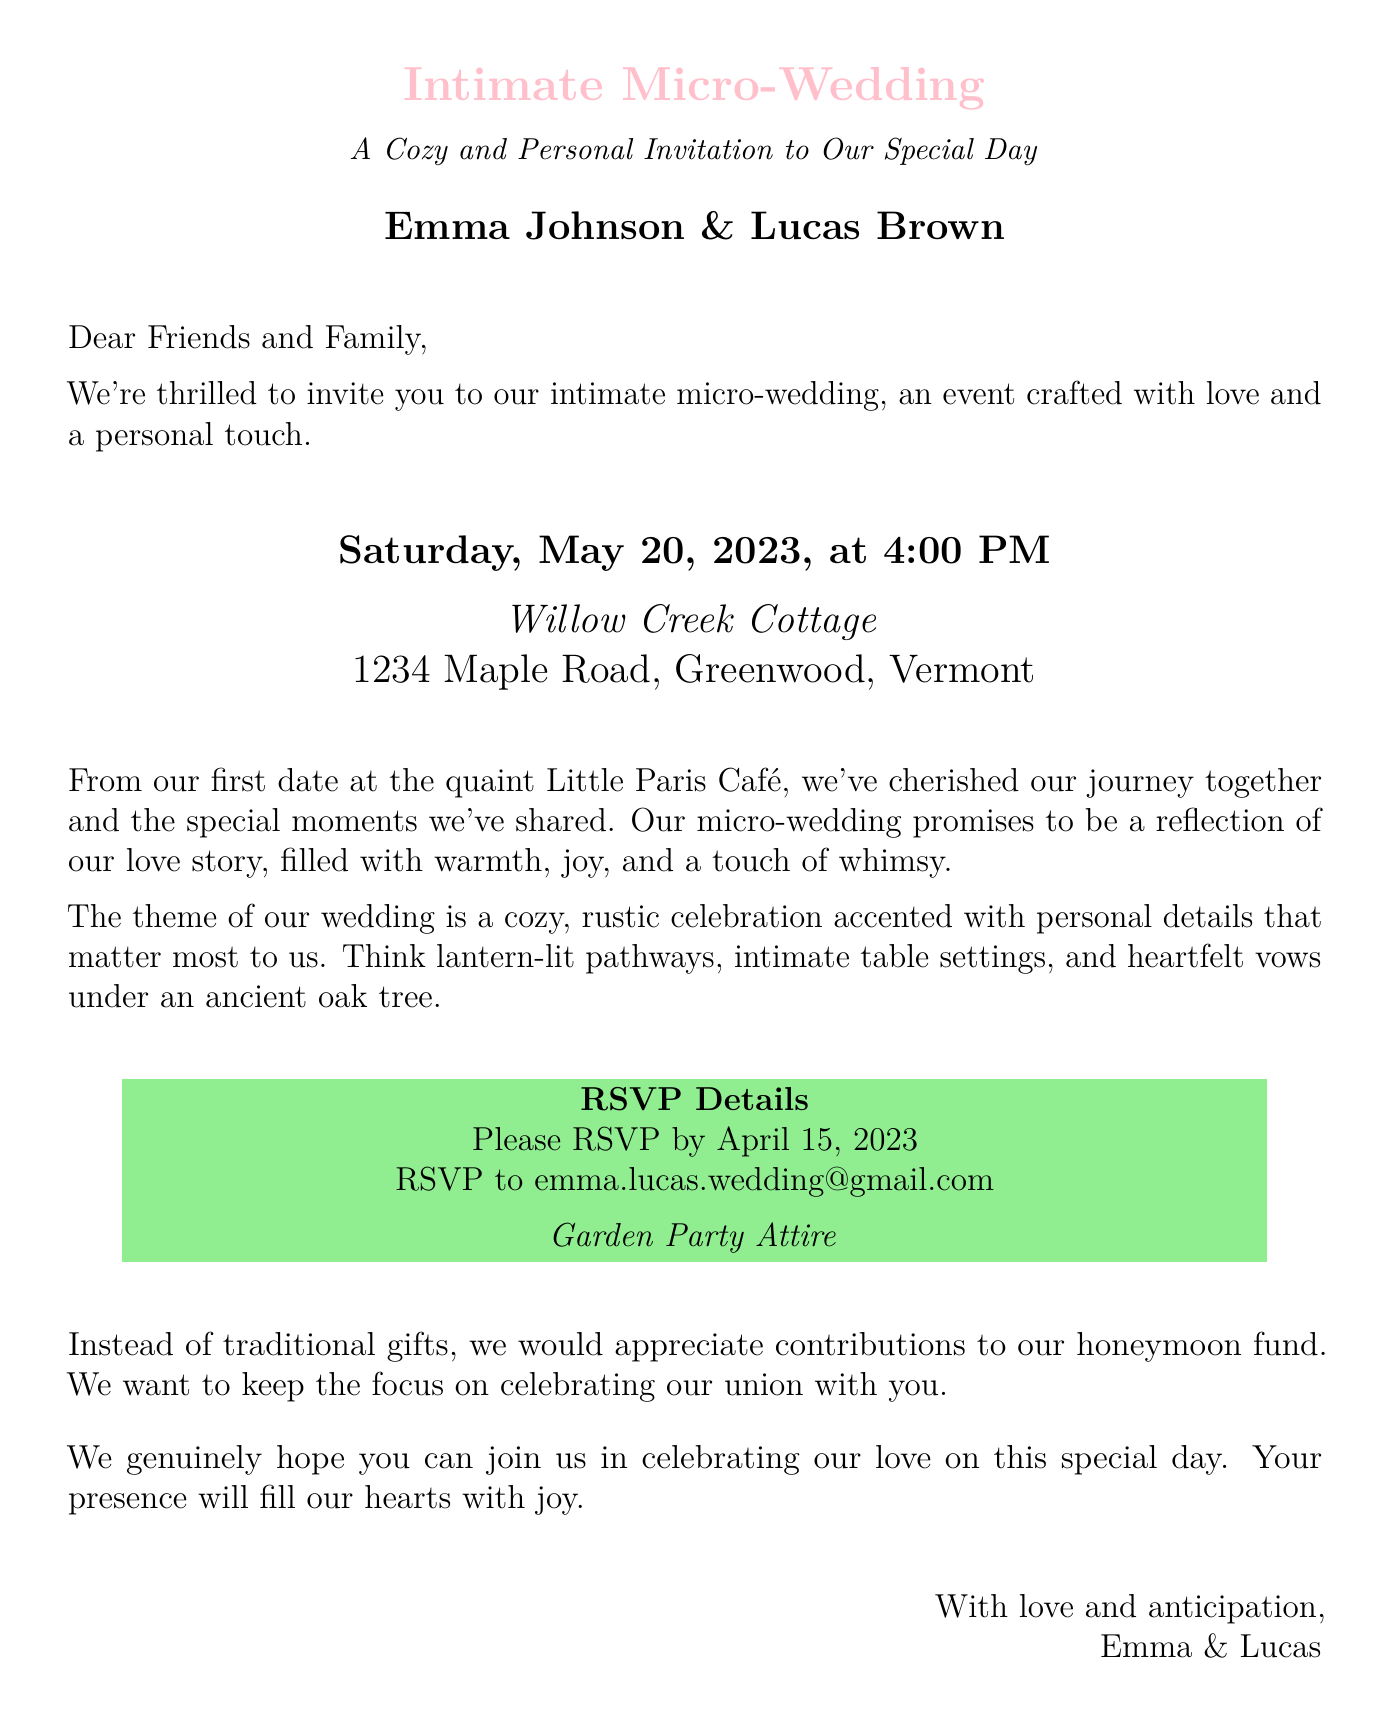What is the date of the wedding? The date of the wedding is specified in the invitation, which is Saturday, May 20, 2023.
Answer: Saturday, May 20, 2023 Who are the couple getting married? The invitation mentions the names of the couple, Emma Johnson and Lucas Brown.
Answer: Emma Johnson & Lucas Brown What is the location of the wedding? The wedding location is provided in the invitation, named Willow Creek Cottage.
Answer: Willow Creek Cottage What is the RSVP deadline? The RSVP deadline is indicated in the RSVP details section, which states to RSVP by April 15, 2023.
Answer: April 15, 2023 What type of attire is requested? The invitation specifies the dress code as "Garden Party Attire."
Answer: Garden Party Attire What is the theme of the wedding? The theme of the wedding is described in the invitation, highlighting a cozy, rustic celebration.
Answer: Cozy, rustic celebration What is requested instead of traditional gifts? The invitation states that contributions to the honeymoon fund are requested instead of traditional gifts.
Answer: Contributions to our honeymoon fund Why is the wedding described as intimate? The invitation mentions it is an intimate micro-wedding crafted with love and a personal touch, emphasizing its small scale.
Answer: Intimate micro-wedding Where did Emma and Lucas have their first date? The invitation recalls that they had their first date at the Little Paris Café.
Answer: Little Paris Café 